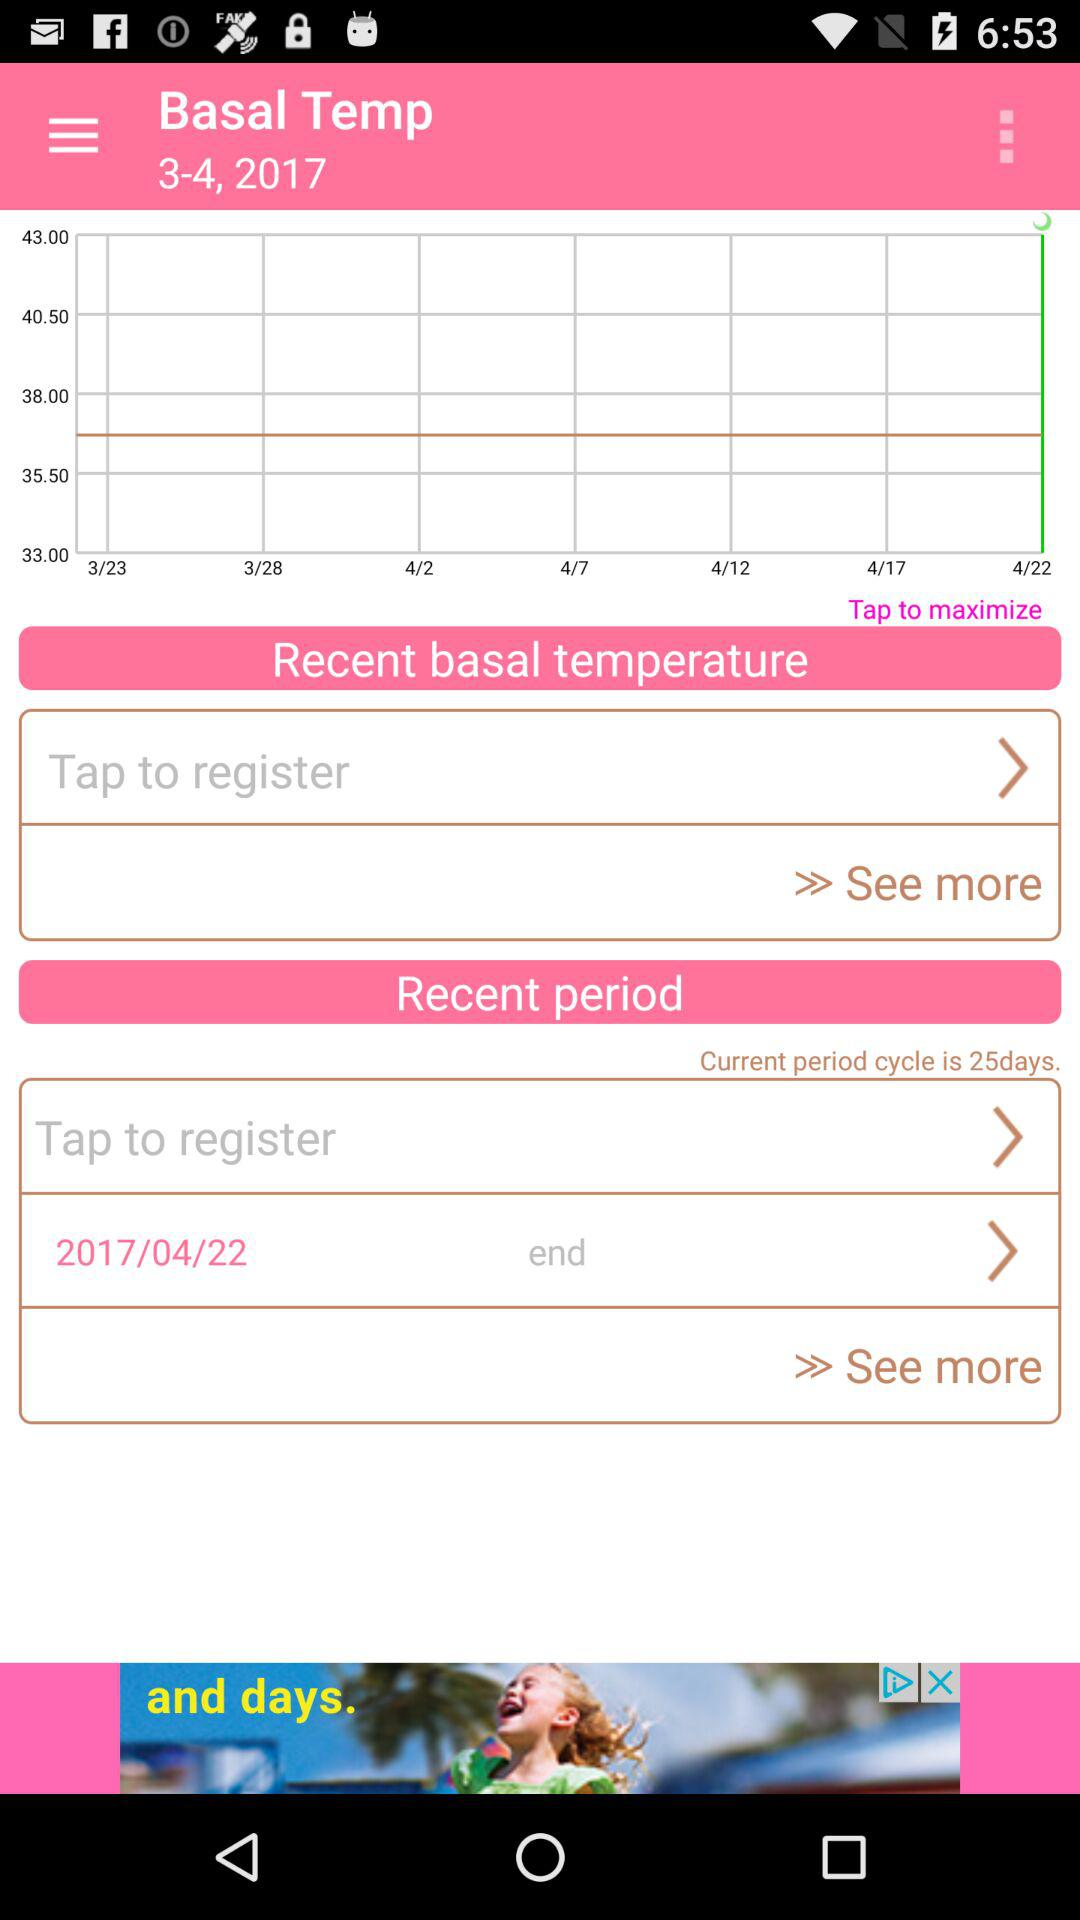On which date the basal temp graph created?
When the provided information is insufficient, respond with <no answer>. <no answer> 